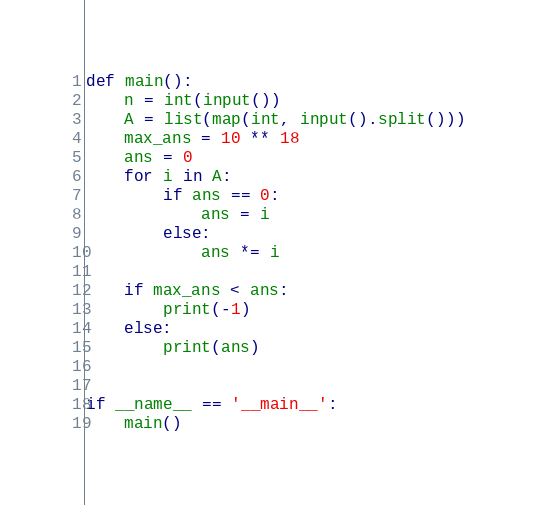Convert code to text. <code><loc_0><loc_0><loc_500><loc_500><_Python_>def main():
    n = int(input())
    A = list(map(int, input().split()))
    max_ans = 10 ** 18
    ans = 0
    for i in A:
        if ans == 0:
            ans = i
        else:
            ans *= i

    if max_ans < ans:
        print(-1)
    else:
        print(ans)


if __name__ == '__main__':
    main()
</code> 